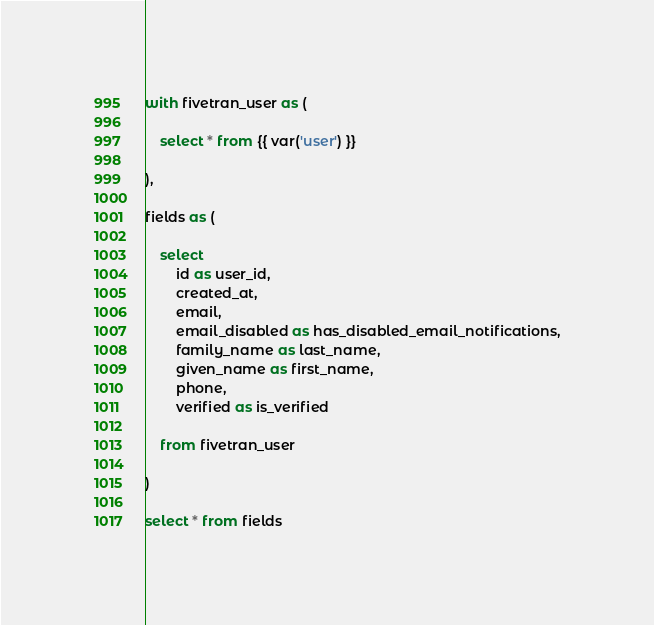Convert code to text. <code><loc_0><loc_0><loc_500><loc_500><_SQL_>with fivetran_user as (

    select * from {{ var('user') }}

),

fields as (

    select
        id as user_id,
        created_at,
        email,
        email_disabled as has_disabled_email_notifications,
        family_name as last_name,
        given_name as first_name,
        phone,
        verified as is_verified
        
    from fivetran_user

)

select * from fields</code> 